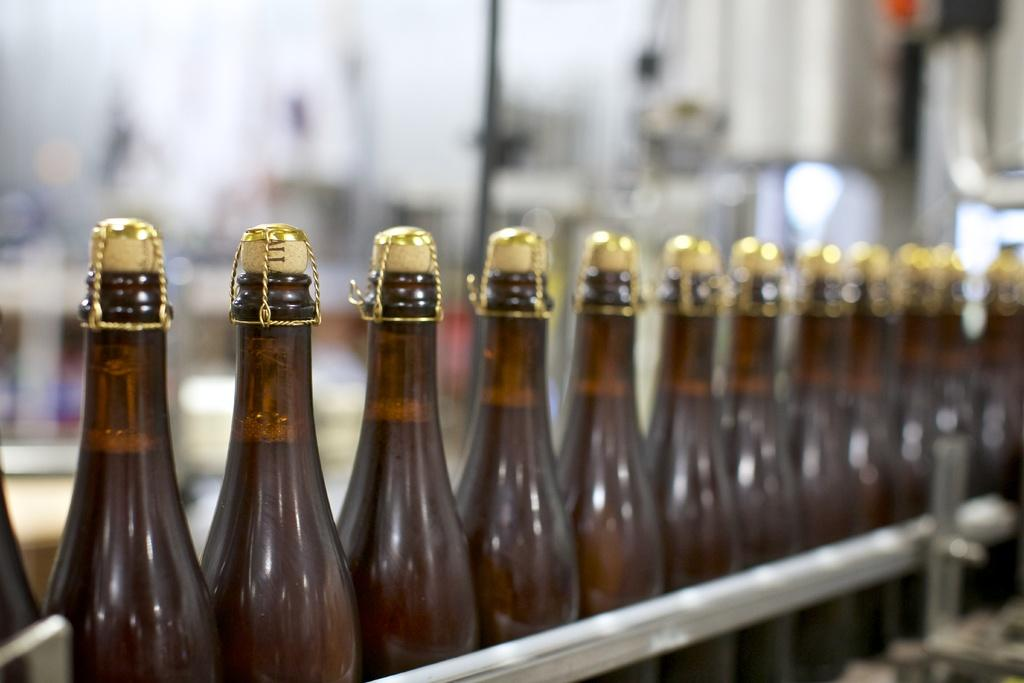What can be seen in the image that is arranged in a sequence manner? There are bottles arranged in a sequence manner in the image. What can be observed about the background of the image? The background of the image is blurry. What type of powder is being used by the judge in the image? There is no judge or powder present in the image; it only features a sequence of bottles with a blurry background. 